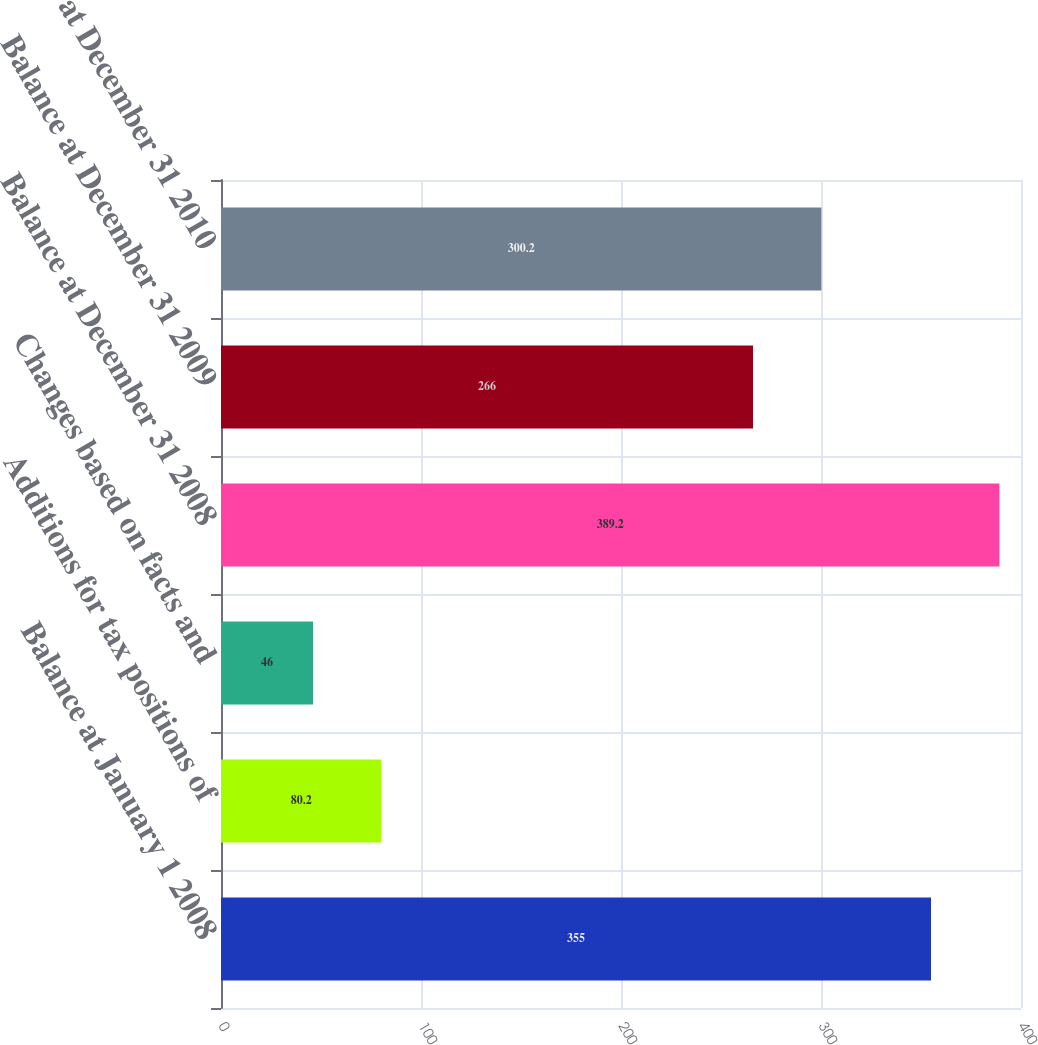Convert chart. <chart><loc_0><loc_0><loc_500><loc_500><bar_chart><fcel>Balance at January 1 2008<fcel>Additions for tax positions of<fcel>Changes based on facts and<fcel>Balance at December 31 2008<fcel>Balance at December 31 2009<fcel>Balance at December 31 2010<nl><fcel>355<fcel>80.2<fcel>46<fcel>389.2<fcel>266<fcel>300.2<nl></chart> 